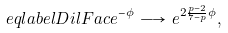<formula> <loc_0><loc_0><loc_500><loc_500>\ e q l a b e l { D i l F a c } e ^ { - \phi } \, \longrightarrow \, e ^ { 2 \frac { p - 2 } { 7 - p } \phi } ,</formula> 